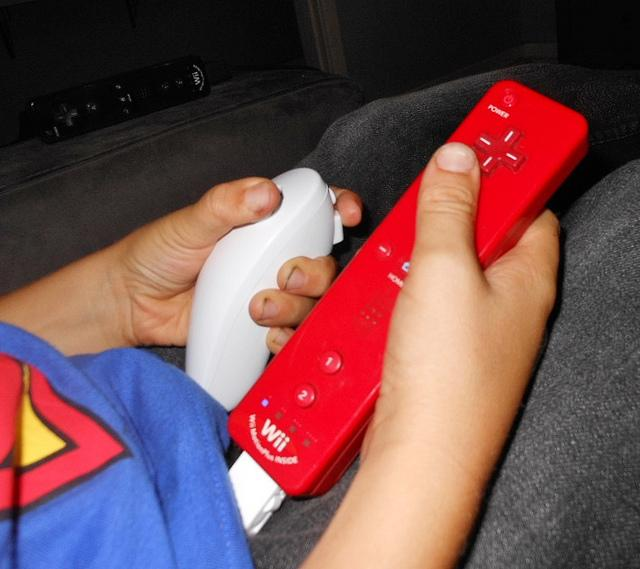What was the first item manufactured by the company that makes the remote? Please explain your reasoning. playing cards. Nintendo is the manufacture of the wii game console and they are know first to make playing cards until they got into making game consoles. 